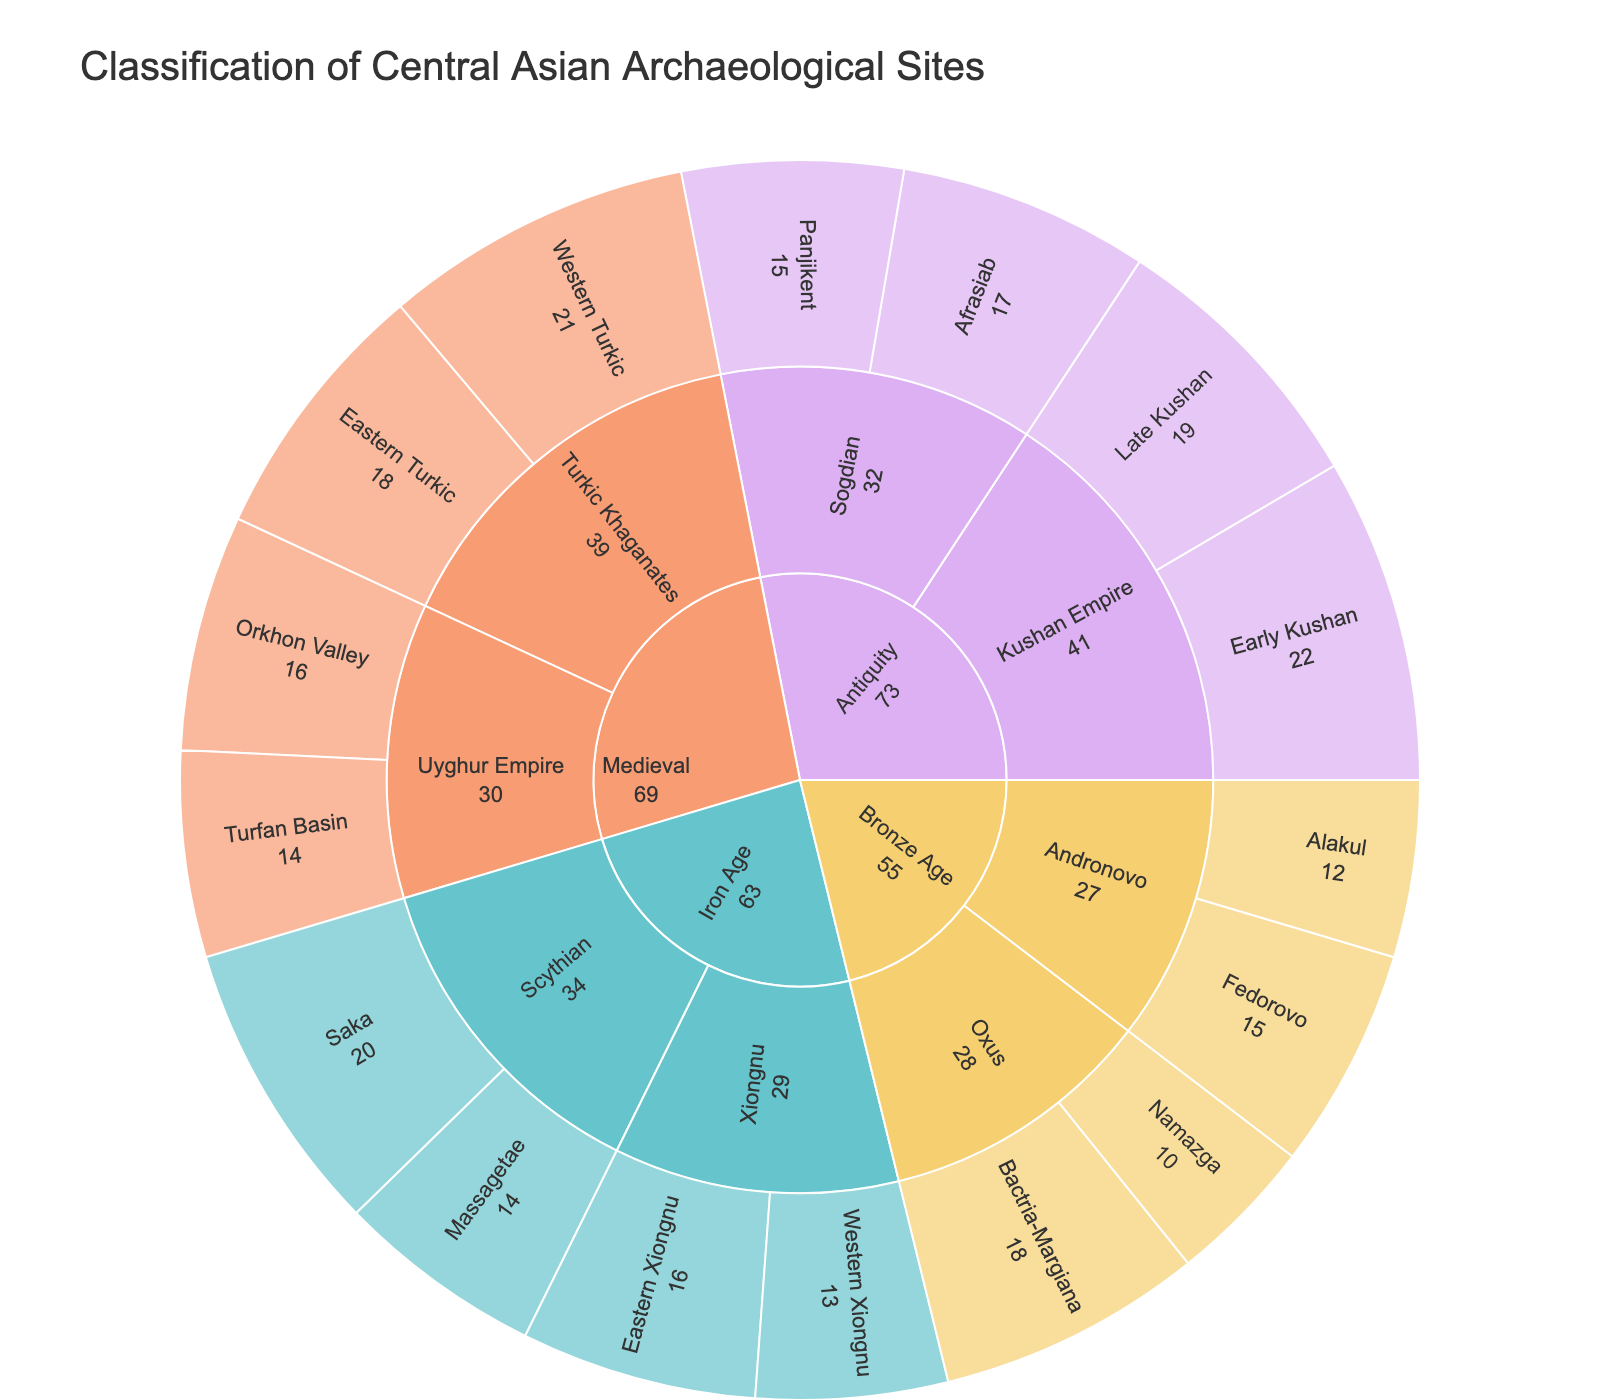Which time period has the most archaeological sites? By examining the outer ring of the sunburst plot, it is clear that the Antiquity period has the largest total value, summing up Early Kushan (22), Late Kushan (19), Afrasiab (17), and Panjikent (15) to get 73.
Answer: Antiquity Which subcategory in the Iron Age includes more sites, Scythian or Xiongnu? According to the sum of values in the subcategories within the Iron Age on the sunburst plot, Scythian has Saka (20) and Massagetae (14) with a total of 34, while Xiongnu has Eastern Xiongnu (16) and Western Xiongnu (13) totaling 29. Thus, Scythian includes more sites.
Answer: Scythian What is the total value of sites classified under the Medieval period? By adding up the values from the sunburst plot: Western Turkic (21) + Eastern Turkic (18) + Orkhon Valley (16) + Turfan Basin (14), the total value is 69.
Answer: 69 Among all the listed sub-subcategories, which one has the highest value? By inspecting the outermost ring of the sunburst plot, Early Kushan from the Antiquity period has the highest value of 22.
Answer: Early Kushan Which culture has the least number of sites? By locating the culture with the smallest sum of subcategories on the sunburst plot: Oxus has Bactria-Margiana (18) and Namazga (10) totaling 28, which is the smallest sum among all cultures.
Answer: Oxus What is the average value of sites within the Bronze Age's Andronovo culture? The total value for Andronovo is Fedorovo (15) + Alakul (12) = 27. Since there are 2 data points, we divide 27 by 2, yielding an average value of 13.5.
Answer: 13.5 How does the total value of sites in the Bronze Age compare to that in the Iron Age? Sum the values for each subcategory in both periods: Bronze Age is Fedorovo (15) + Alakul (12) + Bactria-Margiana (18) + Namazga (10) = 55, and Iron Age is Saka (20) + Massagetae (14) + Eastern Xiongnu (16) + Western Xiongnu (13) = 63. The Iron Age has a higher total value than the Bronze Age.
Answer: Iron Age has more What is the combined value of all sites that belong to the Scythian culture? Adding the values for all sub-subcategories in the Scythian culture: Saka (20) + Massagetae (14), the total is 34.
Answer: 34 Which segment in the Medieval period (either Western Turkic, Eastern Turkic, Orkhon Valley, or Turfan Basin) has the lowest value? Comparing the values in the Medieval period on the sunburst plot, the Turfan Basin segment has the lowest value of 14.
Answer: Turfan Basin 